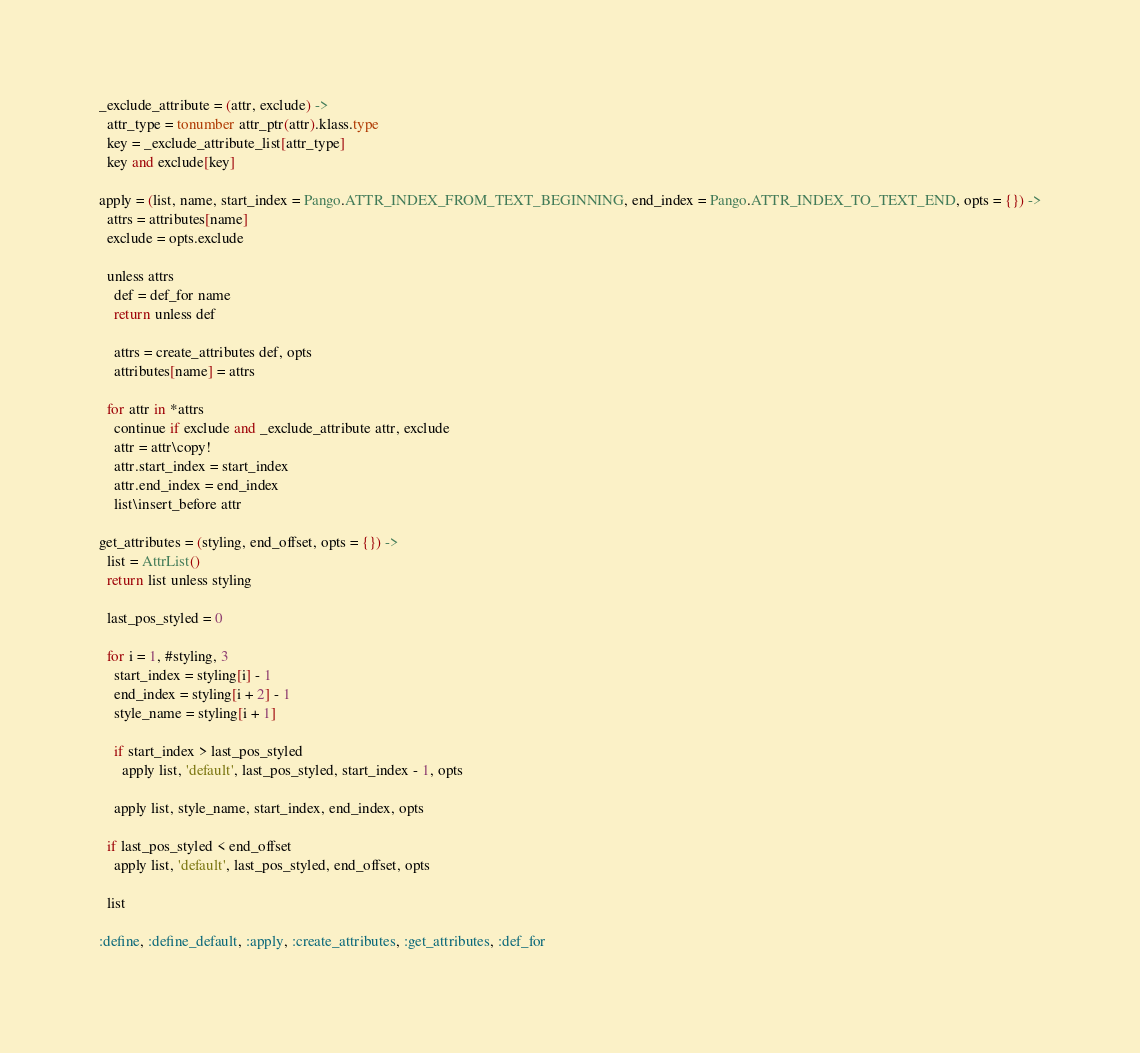Convert code to text. <code><loc_0><loc_0><loc_500><loc_500><_MoonScript_>
_exclude_attribute = (attr, exclude) ->
  attr_type = tonumber attr_ptr(attr).klass.type
  key = _exclude_attribute_list[attr_type]
  key and exclude[key]

apply = (list, name, start_index = Pango.ATTR_INDEX_FROM_TEXT_BEGINNING, end_index = Pango.ATTR_INDEX_TO_TEXT_END, opts = {}) ->
  attrs = attributes[name]
  exclude = opts.exclude

  unless attrs
    def = def_for name
    return unless def

    attrs = create_attributes def, opts
    attributes[name] = attrs

  for attr in *attrs
    continue if exclude and _exclude_attribute attr, exclude
    attr = attr\copy!
    attr.start_index = start_index
    attr.end_index = end_index
    list\insert_before attr

get_attributes = (styling, end_offset, opts = {}) ->
  list = AttrList()
  return list unless styling

  last_pos_styled = 0

  for i = 1, #styling, 3
    start_index = styling[i] - 1
    end_index = styling[i + 2] - 1
    style_name = styling[i + 1]

    if start_index > last_pos_styled
      apply list, 'default', last_pos_styled, start_index - 1, opts

    apply list, style_name, start_index, end_index, opts

  if last_pos_styled < end_offset
    apply list, 'default', last_pos_styled, end_offset, opts

  list

:define, :define_default, :apply, :create_attributes, :get_attributes, :def_for
</code> 